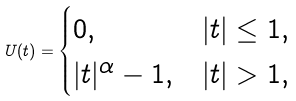<formula> <loc_0><loc_0><loc_500><loc_500>U ( t ) = \begin{cases} 0 , & | t | \leq 1 , \\ | t | ^ { \alpha } - 1 , & | t | > 1 , \end{cases}</formula> 